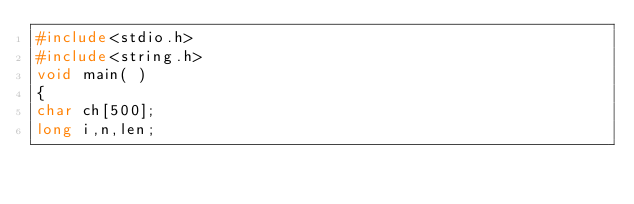Convert code to text. <code><loc_0><loc_0><loc_500><loc_500><_C++_>#include<stdio.h>
#include<string.h>
void main( )
{
char ch[500];
long i,n,len;</code> 